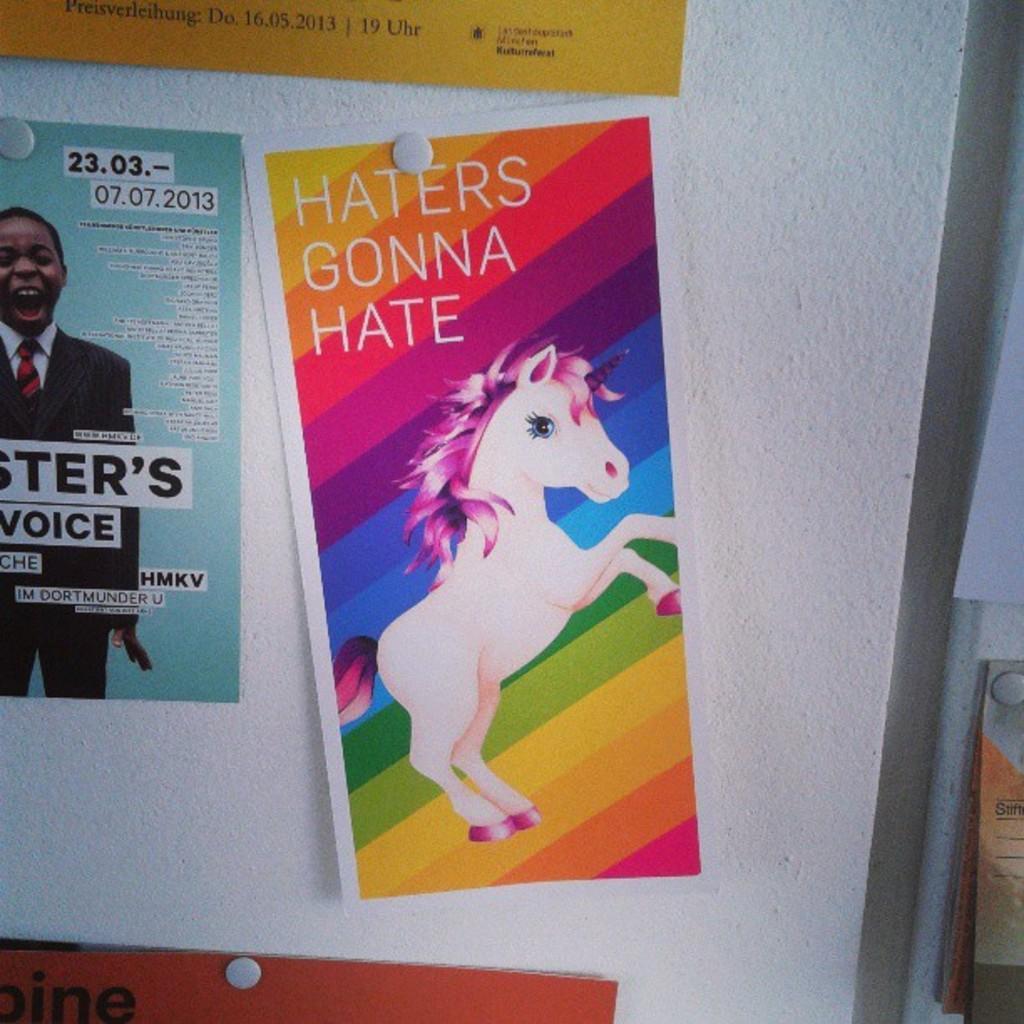Could you give a brief overview of what you see in this image? In this image we can see a posters sticked to the wall. 